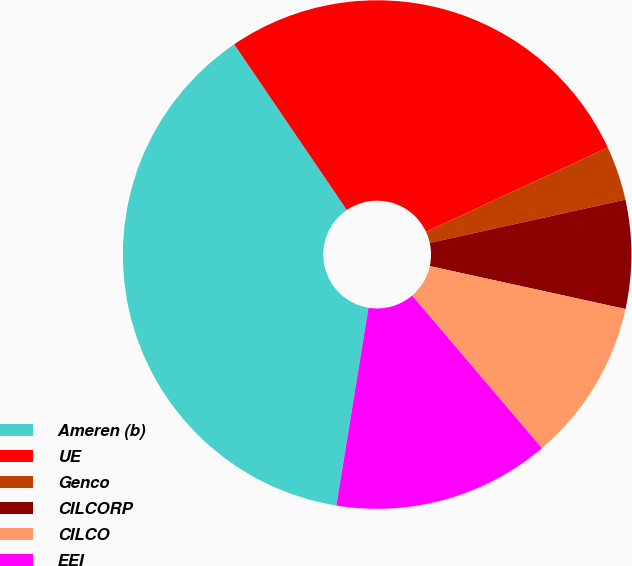Convert chart. <chart><loc_0><loc_0><loc_500><loc_500><pie_chart><fcel>Ameren (b)<fcel>UE<fcel>Genco<fcel>CILCORP<fcel>CILCO<fcel>EEI<nl><fcel>37.93%<fcel>27.59%<fcel>3.45%<fcel>6.9%<fcel>10.34%<fcel>13.79%<nl></chart> 